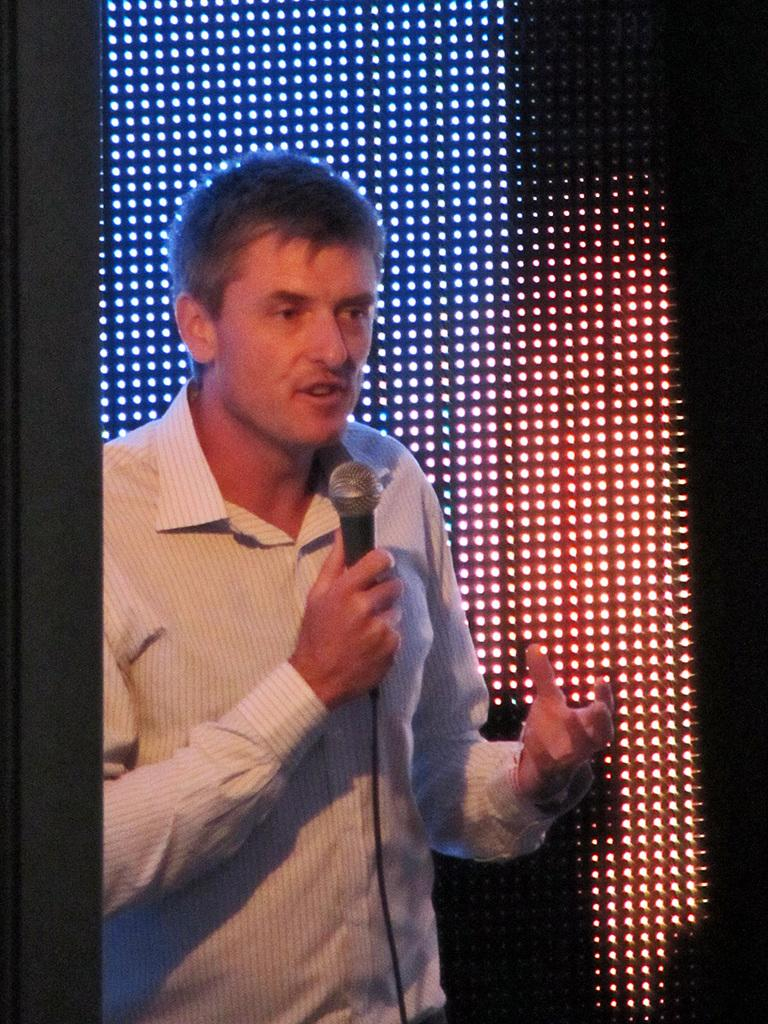What is the main subject of the image? The main subject of the image is a man. What is the man doing in the image? The man is standing in the image. What object is the man holding in the image? The man is holding a mic in the image. What type of interest can be seen hanging from the man's neck in the image? There is no interest visible in the image; the man is holding a mic. What type of hook is the man standing on in the image? There is no hook present in the image; the man is standing on the ground. 